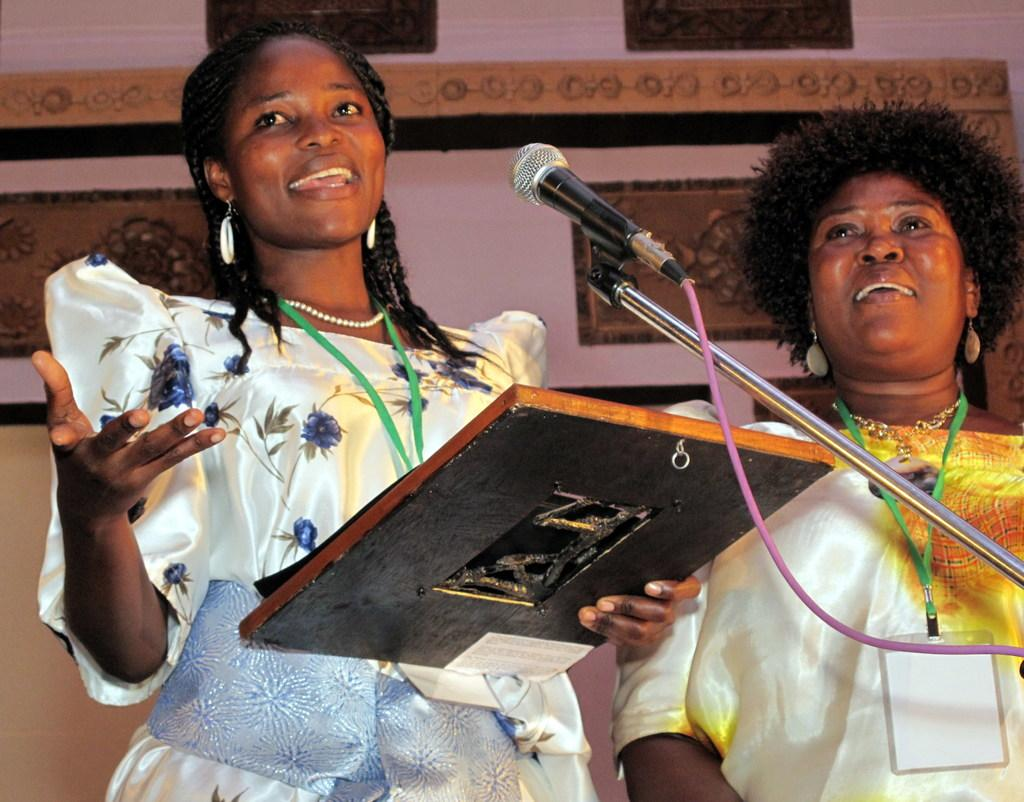How many people are in the image? There are two people standing in the image. What are the people holding in the image? The people are holding something, but the specific object is not mentioned in the facts. What can be seen in front of the people? There is a mic and stand in front of the people. Can you describe the colors in the background of the image? The background of the image has brown, black, and pink colors. What type of territory is being claimed by the people in the image? There is no mention of territory or any claim being made in the image. --- Facts: 1. There is a person sitting on a chair in the image. 2. The person is holding a book. 3. The book has a blue cover. 4. There is a table next to the chair. 5. The table has a lamp on it. Absurd Topics: dance, ocean, machine Conversation: What is the person in the image doing? The person is sitting on a chair in the image. What is the person holding while sitting on the chair? The person is holding a book. Can you describe the book's appearance? The book has a blue cover. What is located next to the chair in the image? There is a table next to the chair. What is on the table? The table has a lamp on it. Reasoning: Let's think step by step in order to produce the conversation. We start by identifying the main subject in the image, which is the person sitting on a chair. Then, we mention that they are holding a book and describe the book's appearance based on the provided facts. Next, we describe the table and its contents, which are a lamp in this case. Each question is designed to elicit a specific detail about the image that is known from the provided facts. Absurd Question/Answer: Can you see any dancing taking place in the image? There is no mention of dancing or any dance-related activity in the image. 